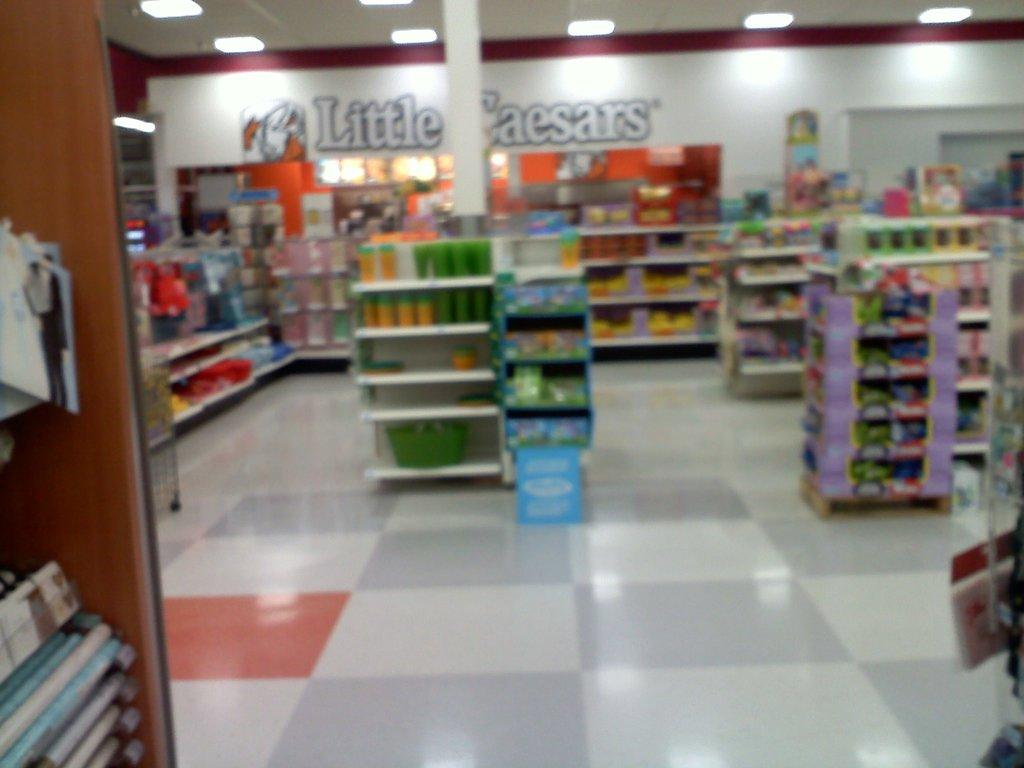<image>
Present a compact description of the photo's key features. The inside of a little ceasers shop with shelves and stands packed with goods. 